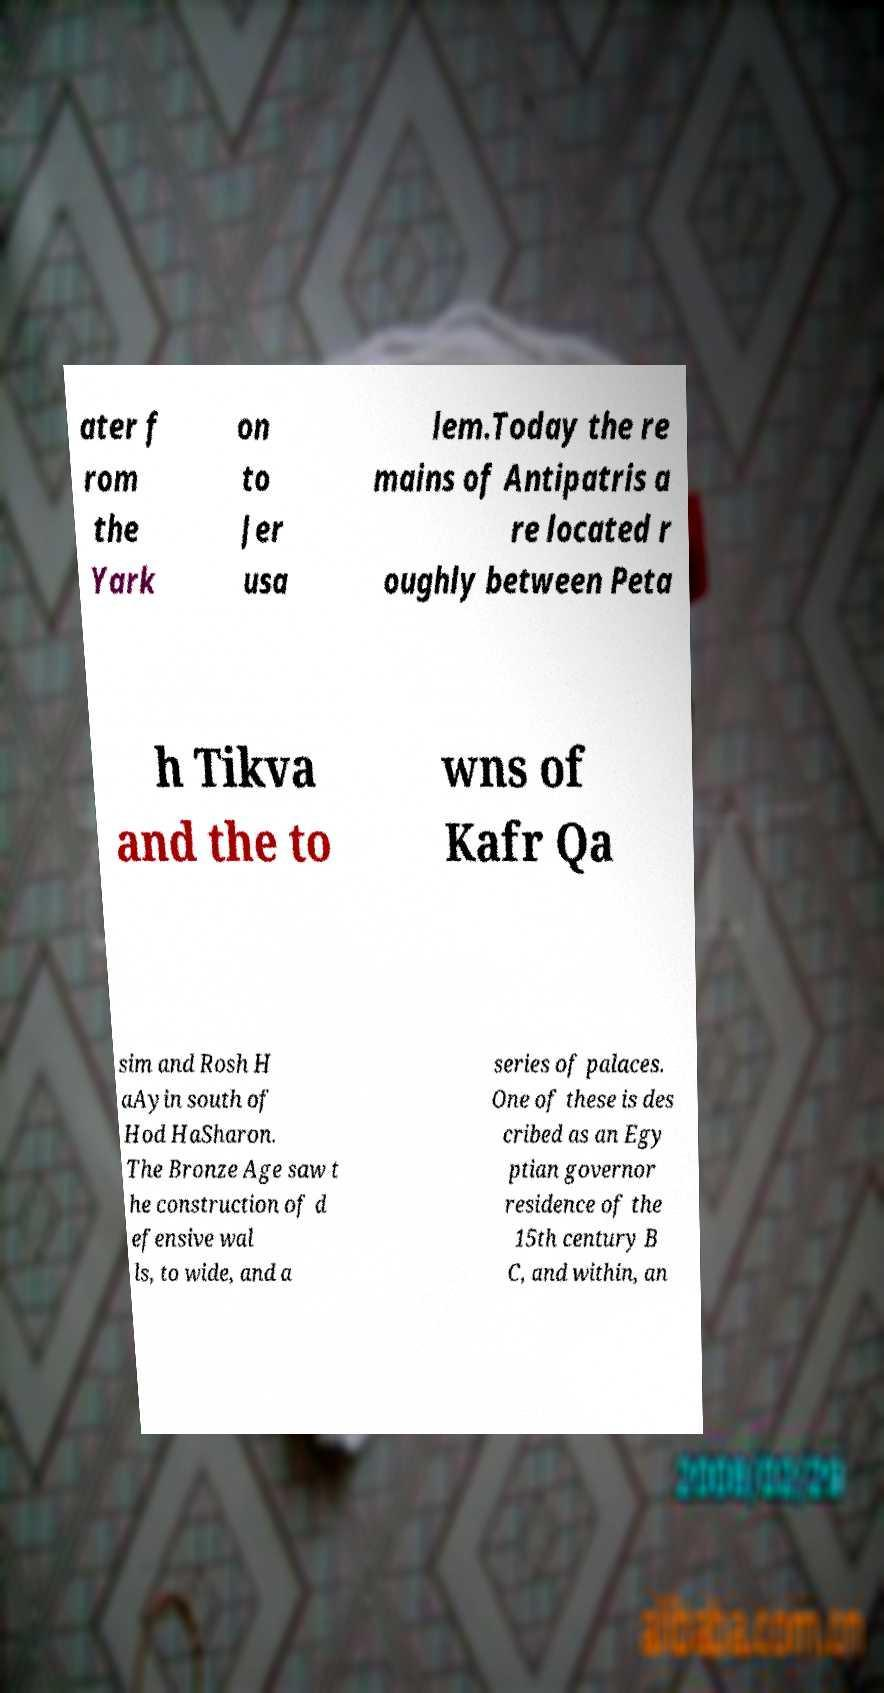Could you extract and type out the text from this image? ater f rom the Yark on to Jer usa lem.Today the re mains of Antipatris a re located r oughly between Peta h Tikva and the to wns of Kafr Qa sim and Rosh H aAyin south of Hod HaSharon. The Bronze Age saw t he construction of d efensive wal ls, to wide, and a series of palaces. One of these is des cribed as an Egy ptian governor residence of the 15th century B C, and within, an 